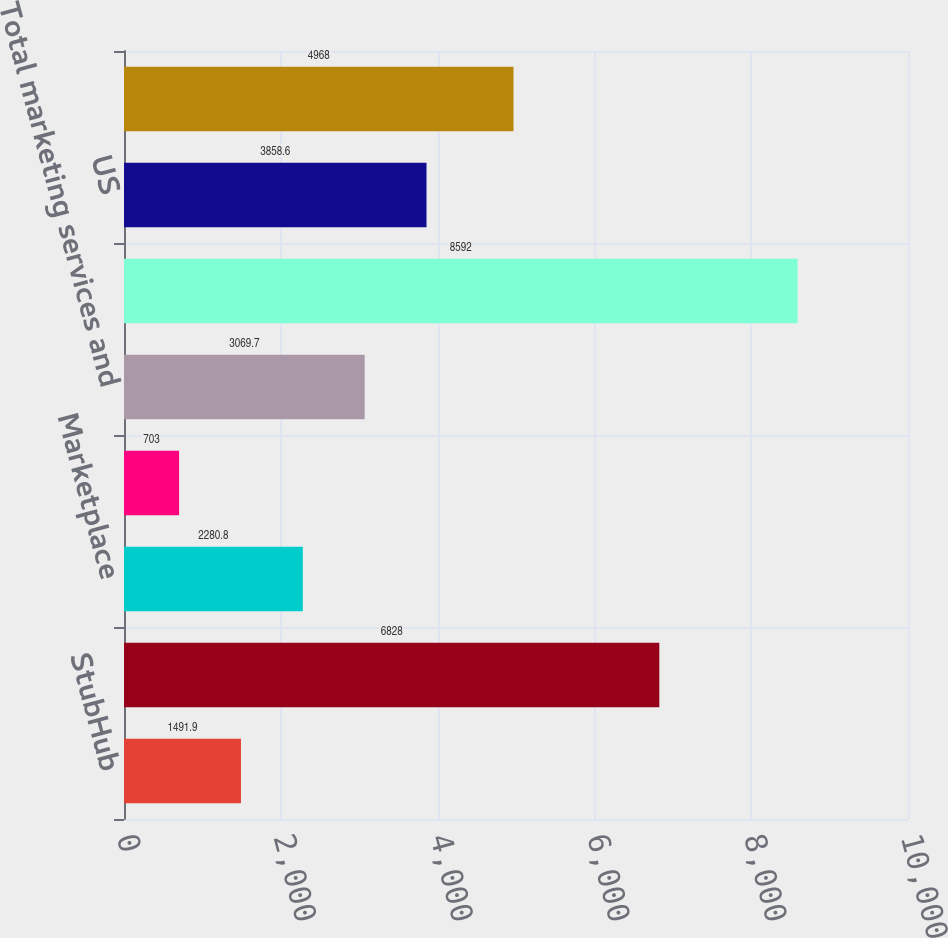<chart> <loc_0><loc_0><loc_500><loc_500><bar_chart><fcel>StubHub<fcel>Total net transaction revenues<fcel>Marketplace<fcel>Classifieds<fcel>Total marketing services and<fcel>Total net revenues<fcel>US<fcel>International<nl><fcel>1491.9<fcel>6828<fcel>2280.8<fcel>703<fcel>3069.7<fcel>8592<fcel>3858.6<fcel>4968<nl></chart> 